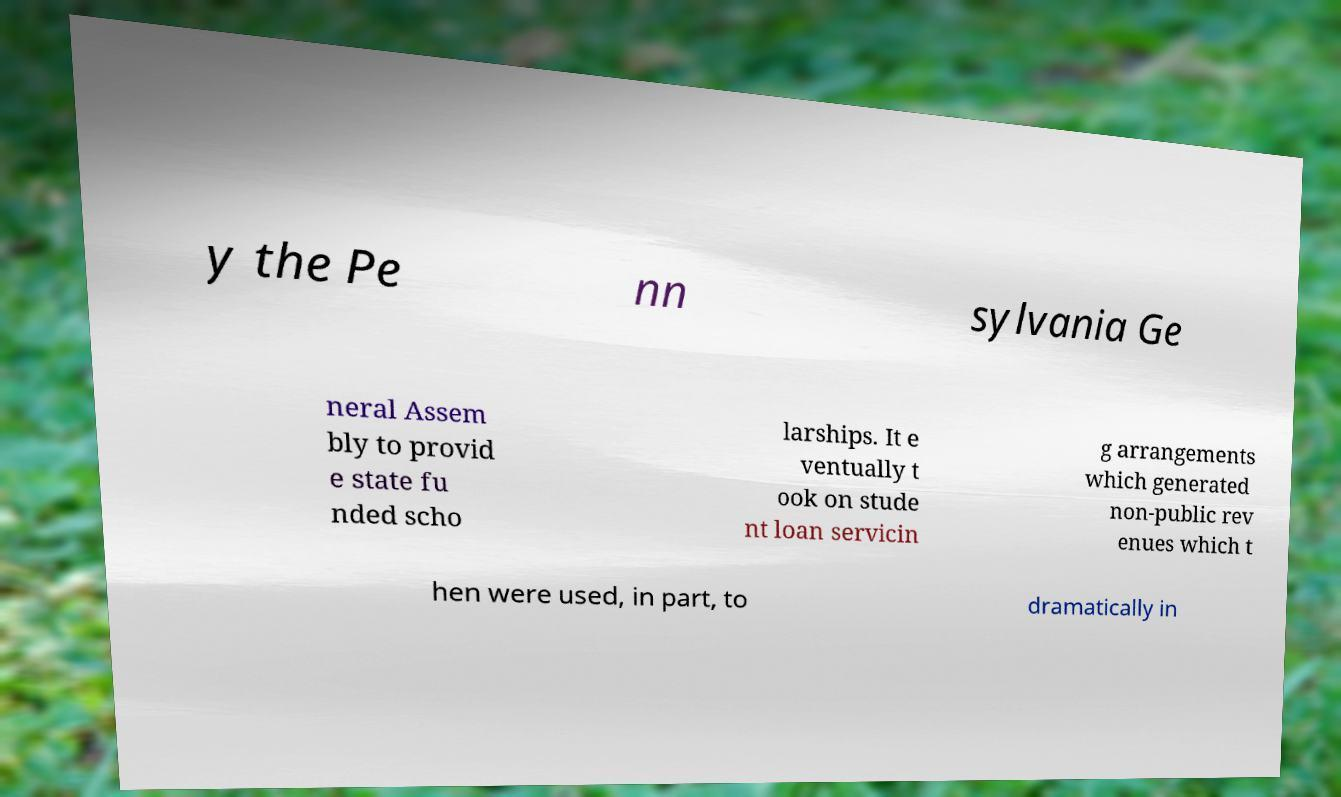Please identify and transcribe the text found in this image. y the Pe nn sylvania Ge neral Assem bly to provid e state fu nded scho larships. It e ventually t ook on stude nt loan servicin g arrangements which generated non-public rev enues which t hen were used, in part, to dramatically in 